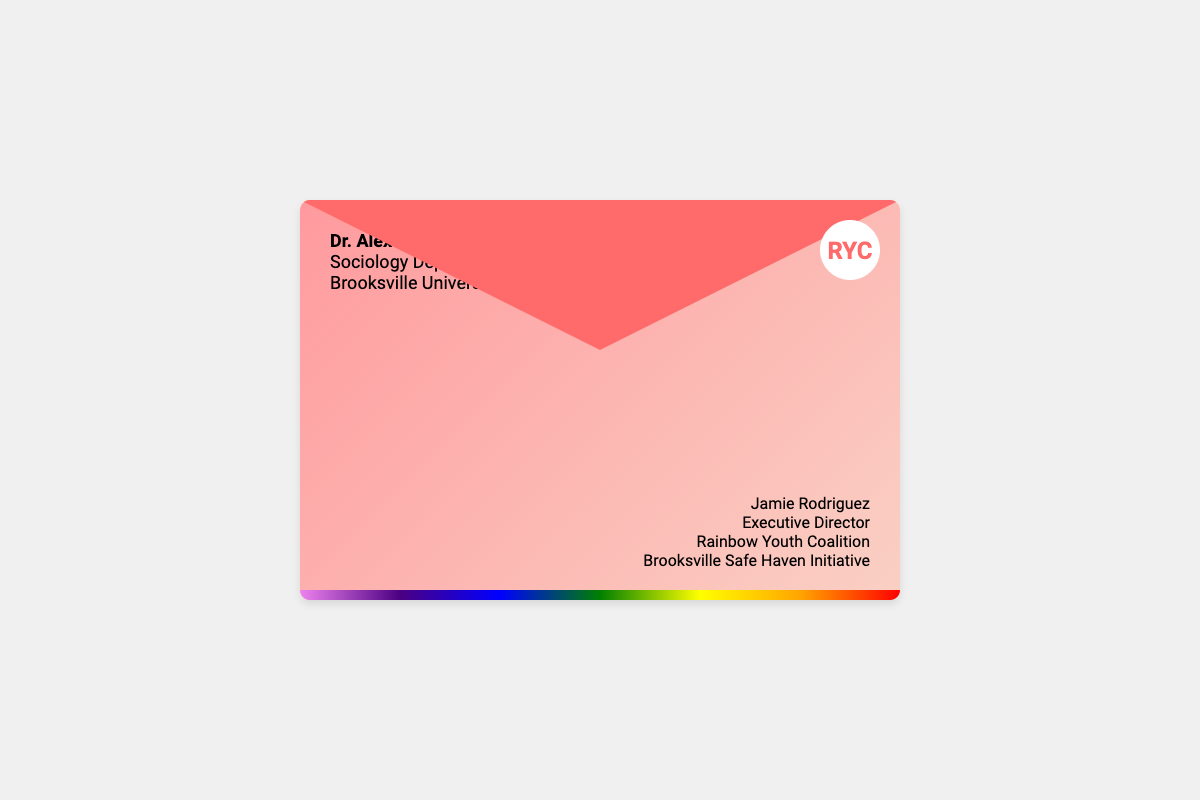What is the recipient's name? The name of the recipient is provided in the document as Dr. Alex Morgan.
Answer: Dr. Alex Morgan What organization is Jamie Rodriguez associated with? Jamie Rodriguez is identified in the document as the Executive Director of the Rainbow Youth Coalition.
Answer: Rainbow Youth Coalition What is the purpose of the Brooksville Safe Haven Initiative? The purpose of the initiative is stated as providing safe housing for LGBTQ youth.
Answer: Safe housing for LGBTQ youth Who is the sender of the letter? The sender's details include their name and title as Jamie Rodriguez, the Executive Director.
Answer: Jamie Rodriguez Which university is mentioned in the document? The document includes Brooksville University as the institution associated with the recipient.
Answer: Brooksville University What is the color of the envelope flap? The envelope flap is described in the document as having a color of #ff6b6b (red).
Answer: #ff6b6b What visual element is at the bottom of the envelope? The bottom of the envelope features a rainbow border as a visual element.
Answer: Rainbow border What type of document is this? The document is identified as an envelope based on its structure and context.
Answer: Envelope 